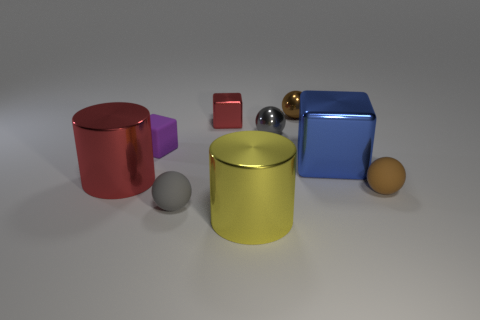Subtract 1 spheres. How many spheres are left? 3 Add 1 small things. How many objects exist? 10 Subtract all cubes. How many objects are left? 6 Subtract 1 yellow cylinders. How many objects are left? 8 Subtract all rubber blocks. Subtract all big brown matte balls. How many objects are left? 8 Add 8 cylinders. How many cylinders are left? 10 Add 9 large purple cylinders. How many large purple cylinders exist? 9 